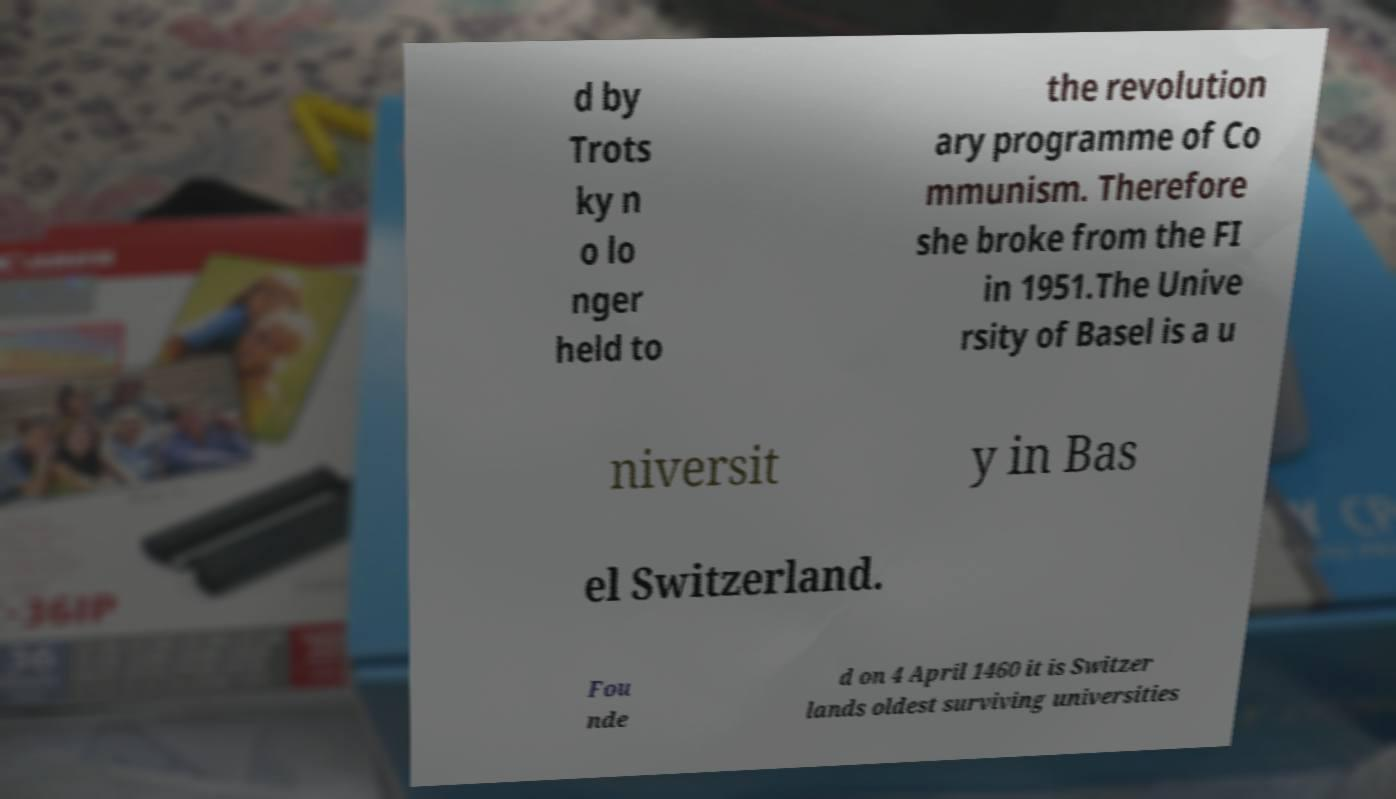Could you extract and type out the text from this image? d by Trots ky n o lo nger held to the revolution ary programme of Co mmunism. Therefore she broke from the FI in 1951.The Unive rsity of Basel is a u niversit y in Bas el Switzerland. Fou nde d on 4 April 1460 it is Switzer lands oldest surviving universities 